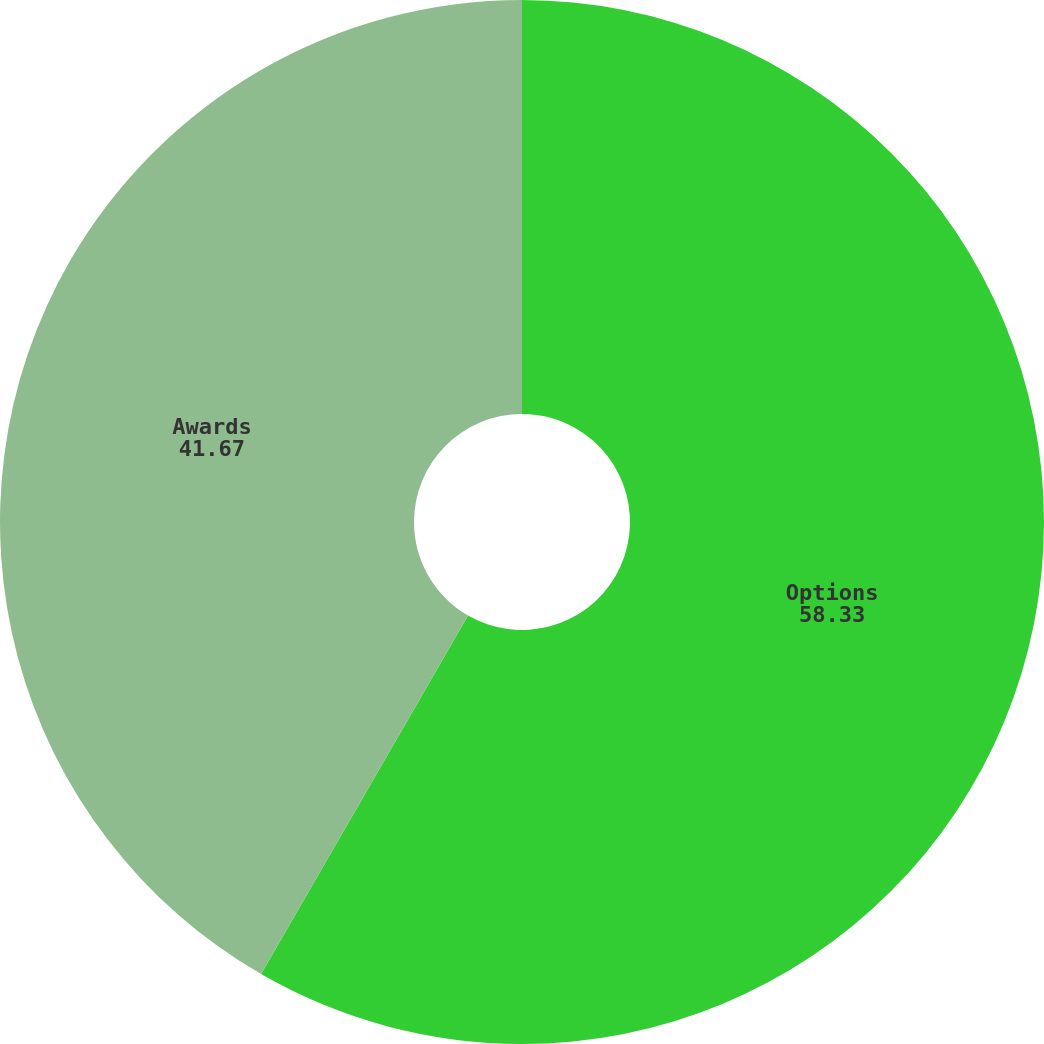<chart> <loc_0><loc_0><loc_500><loc_500><pie_chart><fcel>Options<fcel>Awards<nl><fcel>58.33%<fcel>41.67%<nl></chart> 